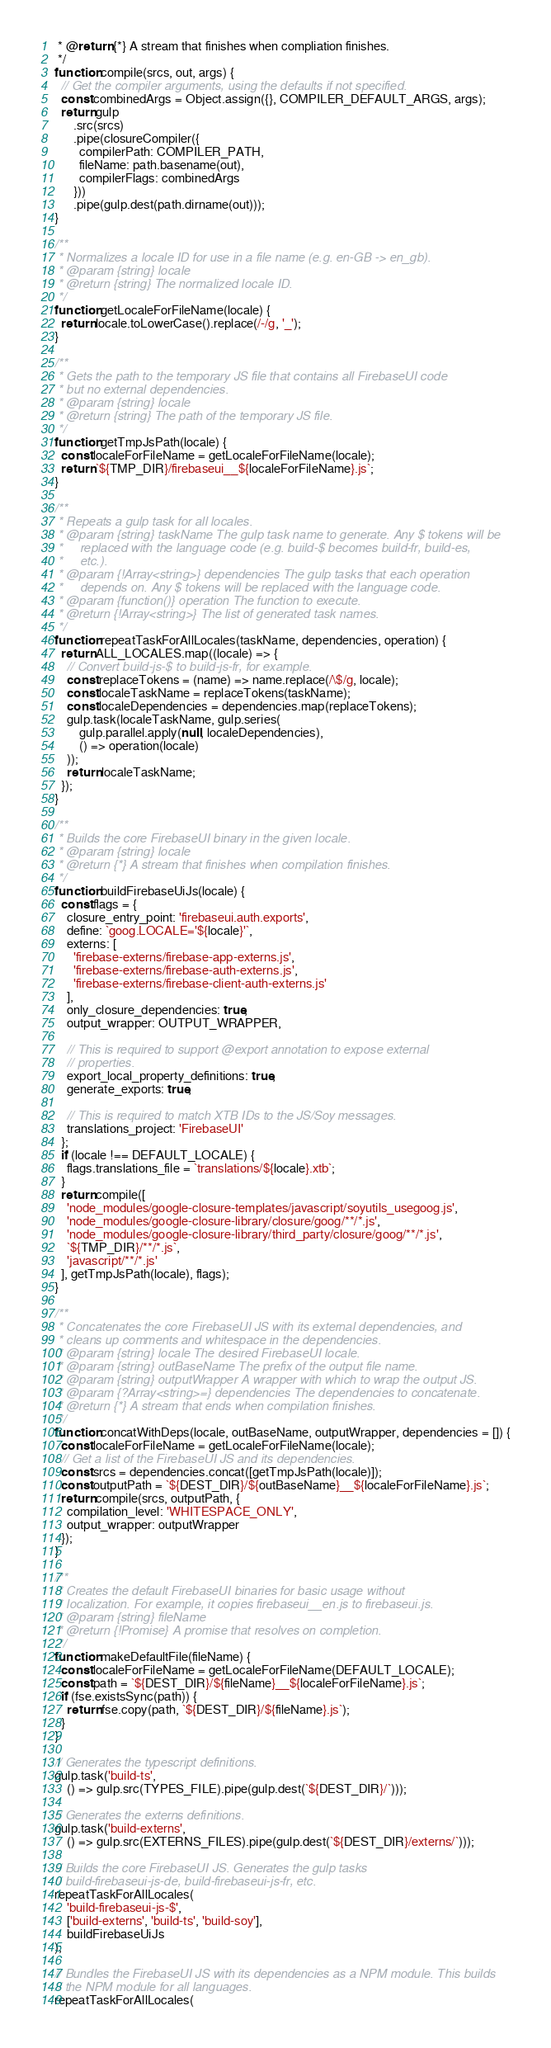Convert code to text. <code><loc_0><loc_0><loc_500><loc_500><_JavaScript_> * @return {*} A stream that finishes when compliation finishes.
 */
function compile(srcs, out, args) {
  // Get the compiler arguments, using the defaults if not specified.
  const combinedArgs = Object.assign({}, COMPILER_DEFAULT_ARGS, args);
  return gulp
      .src(srcs)
      .pipe(closureCompiler({
        compilerPath: COMPILER_PATH,
        fileName: path.basename(out),
        compilerFlags: combinedArgs
      }))
      .pipe(gulp.dest(path.dirname(out)));
}

/**
 * Normalizes a locale ID for use in a file name (e.g. en-GB -> en_gb).
 * @param {string} locale
 * @return {string} The normalized locale ID.
 */
function getLocaleForFileName(locale) {
  return locale.toLowerCase().replace(/-/g, '_');
}

/**
 * Gets the path to the temporary JS file that contains all FirebaseUI code
 * but no external dependencies.
 * @param {string} locale
 * @return {string} The path of the temporary JS file.
 */
function getTmpJsPath(locale) {
  const localeForFileName = getLocaleForFileName(locale);
  return `${TMP_DIR}/firebaseui__${localeForFileName}.js`;
}

/**
 * Repeats a gulp task for all locales.
 * @param {string} taskName The gulp task name to generate. Any $ tokens will be
 *     replaced with the language code (e.g. build-$ becomes build-fr, build-es,
 *     etc.).
 * @param {!Array<string>} dependencies The gulp tasks that each operation
 *     depends on. Any $ tokens will be replaced with the language code.
 * @param {function()} operation The function to execute.
 * @return {!Array<string>} The list of generated task names.
 */
function repeatTaskForAllLocales(taskName, dependencies, operation) {
  return ALL_LOCALES.map((locale) => {
    // Convert build-js-$ to build-js-fr, for example.
    const replaceTokens = (name) => name.replace(/\$/g, locale);
    const localeTaskName = replaceTokens(taskName);
    const localeDependencies = dependencies.map(replaceTokens);
    gulp.task(localeTaskName, gulp.series(
        gulp.parallel.apply(null, localeDependencies),
        () => operation(locale)
    ));
    return localeTaskName;
  });
}

/**
 * Builds the core FirebaseUI binary in the given locale.
 * @param {string} locale
 * @return {*} A stream that finishes when compilation finishes.
 */
function buildFirebaseUiJs(locale) {
  const flags = {
    closure_entry_point: 'firebaseui.auth.exports',
    define: `goog.LOCALE='${locale}'`,
    externs: [
      'firebase-externs/firebase-app-externs.js',
      'firebase-externs/firebase-auth-externs.js',
      'firebase-externs/firebase-client-auth-externs.js'
    ],
    only_closure_dependencies: true,
    output_wrapper: OUTPUT_WRAPPER,

    // This is required to support @export annotation to expose external
    // properties.
    export_local_property_definitions: true,
    generate_exports: true,

    // This is required to match XTB IDs to the JS/Soy messages.
    translations_project: 'FirebaseUI'
  };
  if (locale !== DEFAULT_LOCALE) {
    flags.translations_file = `translations/${locale}.xtb`;
  }
  return compile([
    'node_modules/google-closure-templates/javascript/soyutils_usegoog.js',
    'node_modules/google-closure-library/closure/goog/**/*.js',
    'node_modules/google-closure-library/third_party/closure/goog/**/*.js',
    `${TMP_DIR}/**/*.js`,
    'javascript/**/*.js'
  ], getTmpJsPath(locale), flags);
}

/**
 * Concatenates the core FirebaseUI JS with its external dependencies, and
 * cleans up comments and whitespace in the dependencies.
 * @param {string} locale The desired FirebaseUI locale.
 * @param {string} outBaseName The prefix of the output file name.
 * @param {string} outputWrapper A wrapper with which to wrap the output JS.
 * @param {?Array<string>=} dependencies The dependencies to concatenate.
 * @return {*} A stream that ends when compilation finishes.
 */
function concatWithDeps(locale, outBaseName, outputWrapper, dependencies = []) {
  const localeForFileName = getLocaleForFileName(locale);
  // Get a list of the FirebaseUI JS and its dependencies.
  const srcs = dependencies.concat([getTmpJsPath(locale)]);
  const outputPath = `${DEST_DIR}/${outBaseName}__${localeForFileName}.js`;
  return compile(srcs, outputPath, {
    compilation_level: 'WHITESPACE_ONLY',
    output_wrapper: outputWrapper
  });
}

/**
 * Creates the default FirebaseUI binaries for basic usage without
 * localization. For example, it copies firebaseui__en.js to firebaseui.js.
 * @param {string} fileName
 * @return {!Promise} A promise that resolves on completion.
 */
function makeDefaultFile(fileName) {
  const localeForFileName = getLocaleForFileName(DEFAULT_LOCALE);
  const path = `${DEST_DIR}/${fileName}__${localeForFileName}.js`;
  if (fse.existsSync(path)) {
    return fse.copy(path, `${DEST_DIR}/${fileName}.js`);
  }
}

// Generates the typescript definitions.
gulp.task('build-ts',
    () => gulp.src(TYPES_FILE).pipe(gulp.dest(`${DEST_DIR}/`)));

// Generates the externs definitions.
gulp.task('build-externs',
    () => gulp.src(EXTERNS_FILES).pipe(gulp.dest(`${DEST_DIR}/externs/`)));

// Builds the core FirebaseUI JS. Generates the gulp tasks
// build-firebaseui-js-de, build-firebaseui-js-fr, etc.
repeatTaskForAllLocales(
    'build-firebaseui-js-$',
    ['build-externs', 'build-ts', 'build-soy'],
    buildFirebaseUiJs
);

// Bundles the FirebaseUI JS with its dependencies as a NPM module. This builds
// the NPM module for all languages.
repeatTaskForAllLocales(</code> 